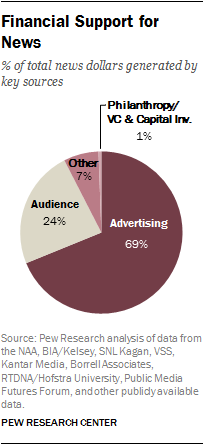Identify some key points in this picture. The percentage value of the audience in the chart is 24%. The sum of the percentage of advertising and audience is 93%. 